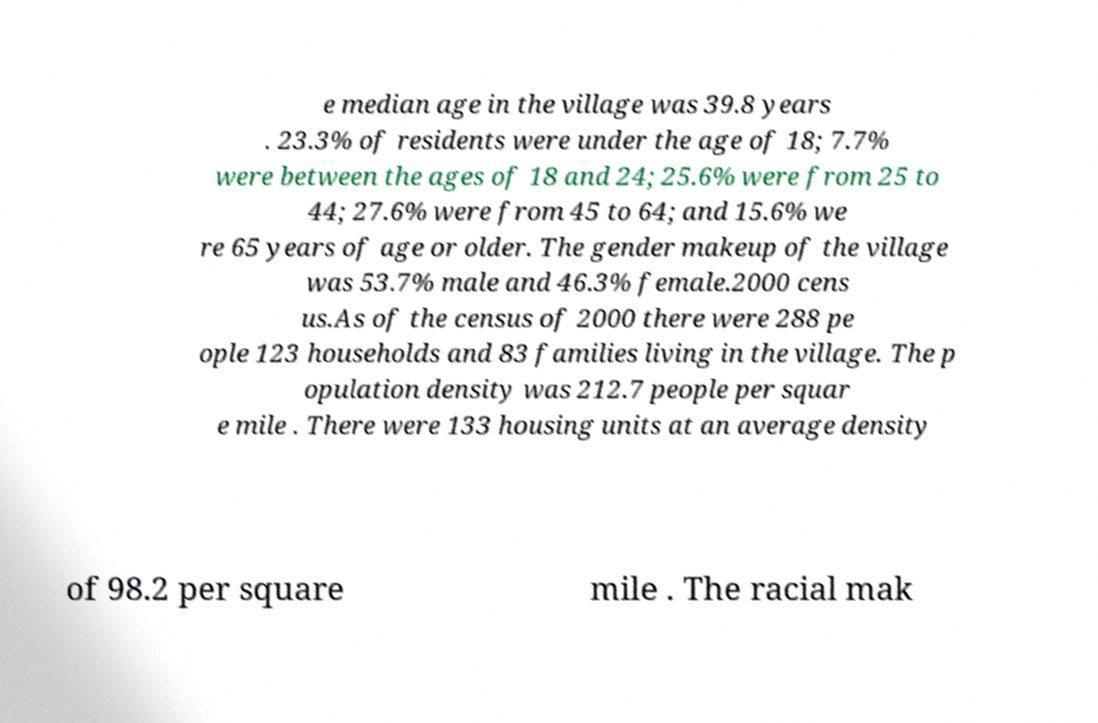Can you read and provide the text displayed in the image?This photo seems to have some interesting text. Can you extract and type it out for me? e median age in the village was 39.8 years . 23.3% of residents were under the age of 18; 7.7% were between the ages of 18 and 24; 25.6% were from 25 to 44; 27.6% were from 45 to 64; and 15.6% we re 65 years of age or older. The gender makeup of the village was 53.7% male and 46.3% female.2000 cens us.As of the census of 2000 there were 288 pe ople 123 households and 83 families living in the village. The p opulation density was 212.7 people per squar e mile . There were 133 housing units at an average density of 98.2 per square mile . The racial mak 